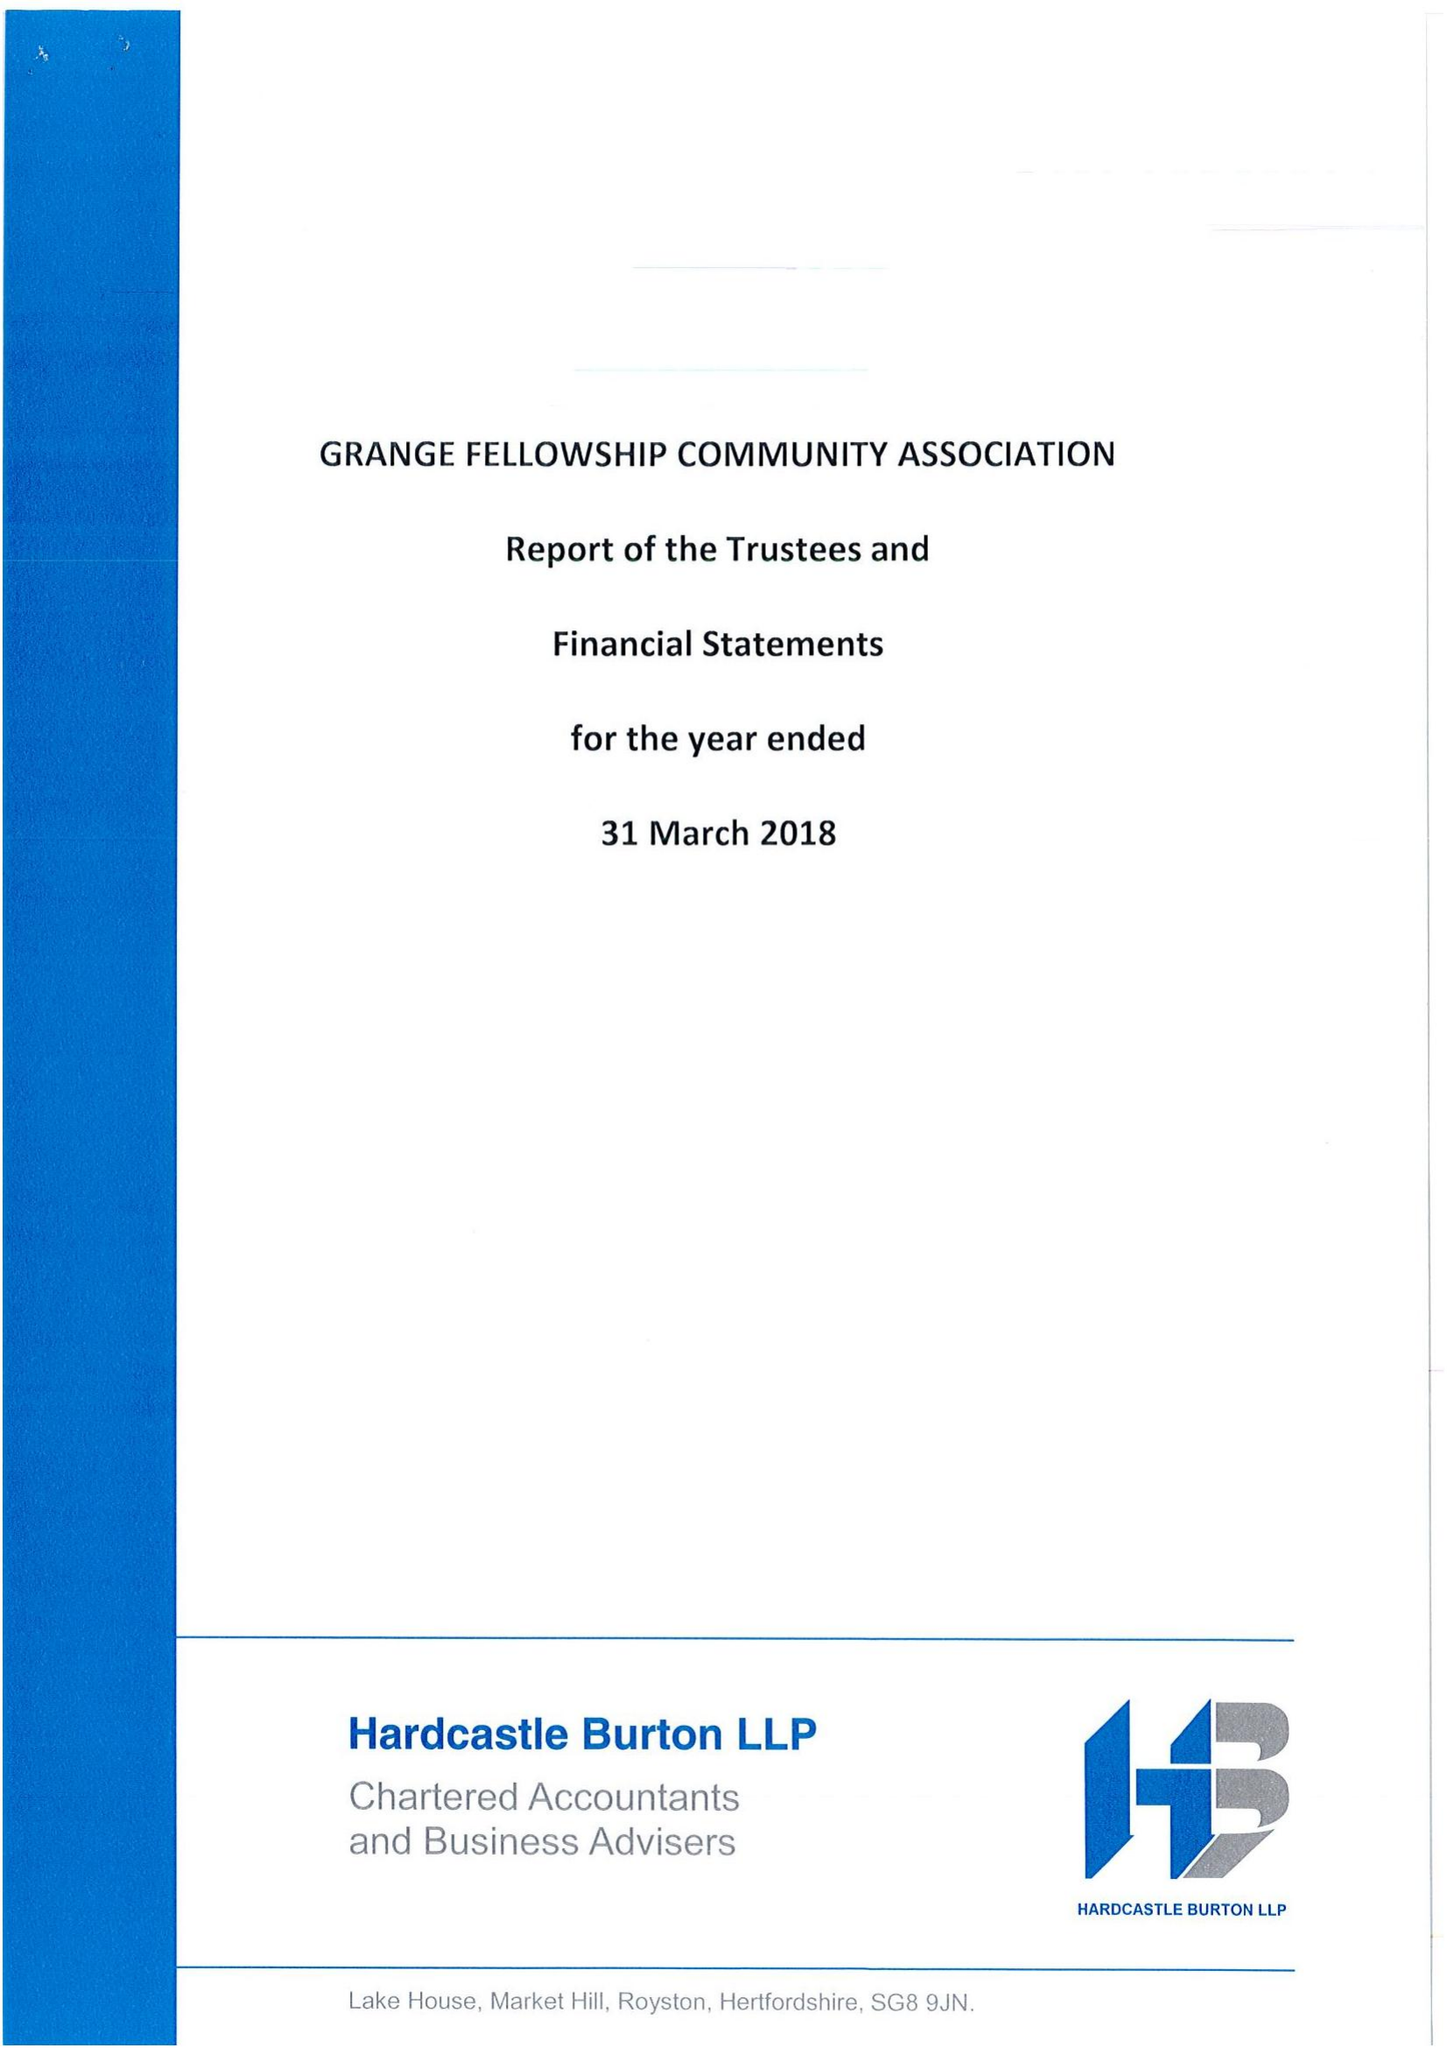What is the value for the charity_number?
Answer the question using a single word or phrase. 302420 